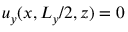<formula> <loc_0><loc_0><loc_500><loc_500>u _ { y } ( x , L _ { y } / 2 , z ) = 0</formula> 